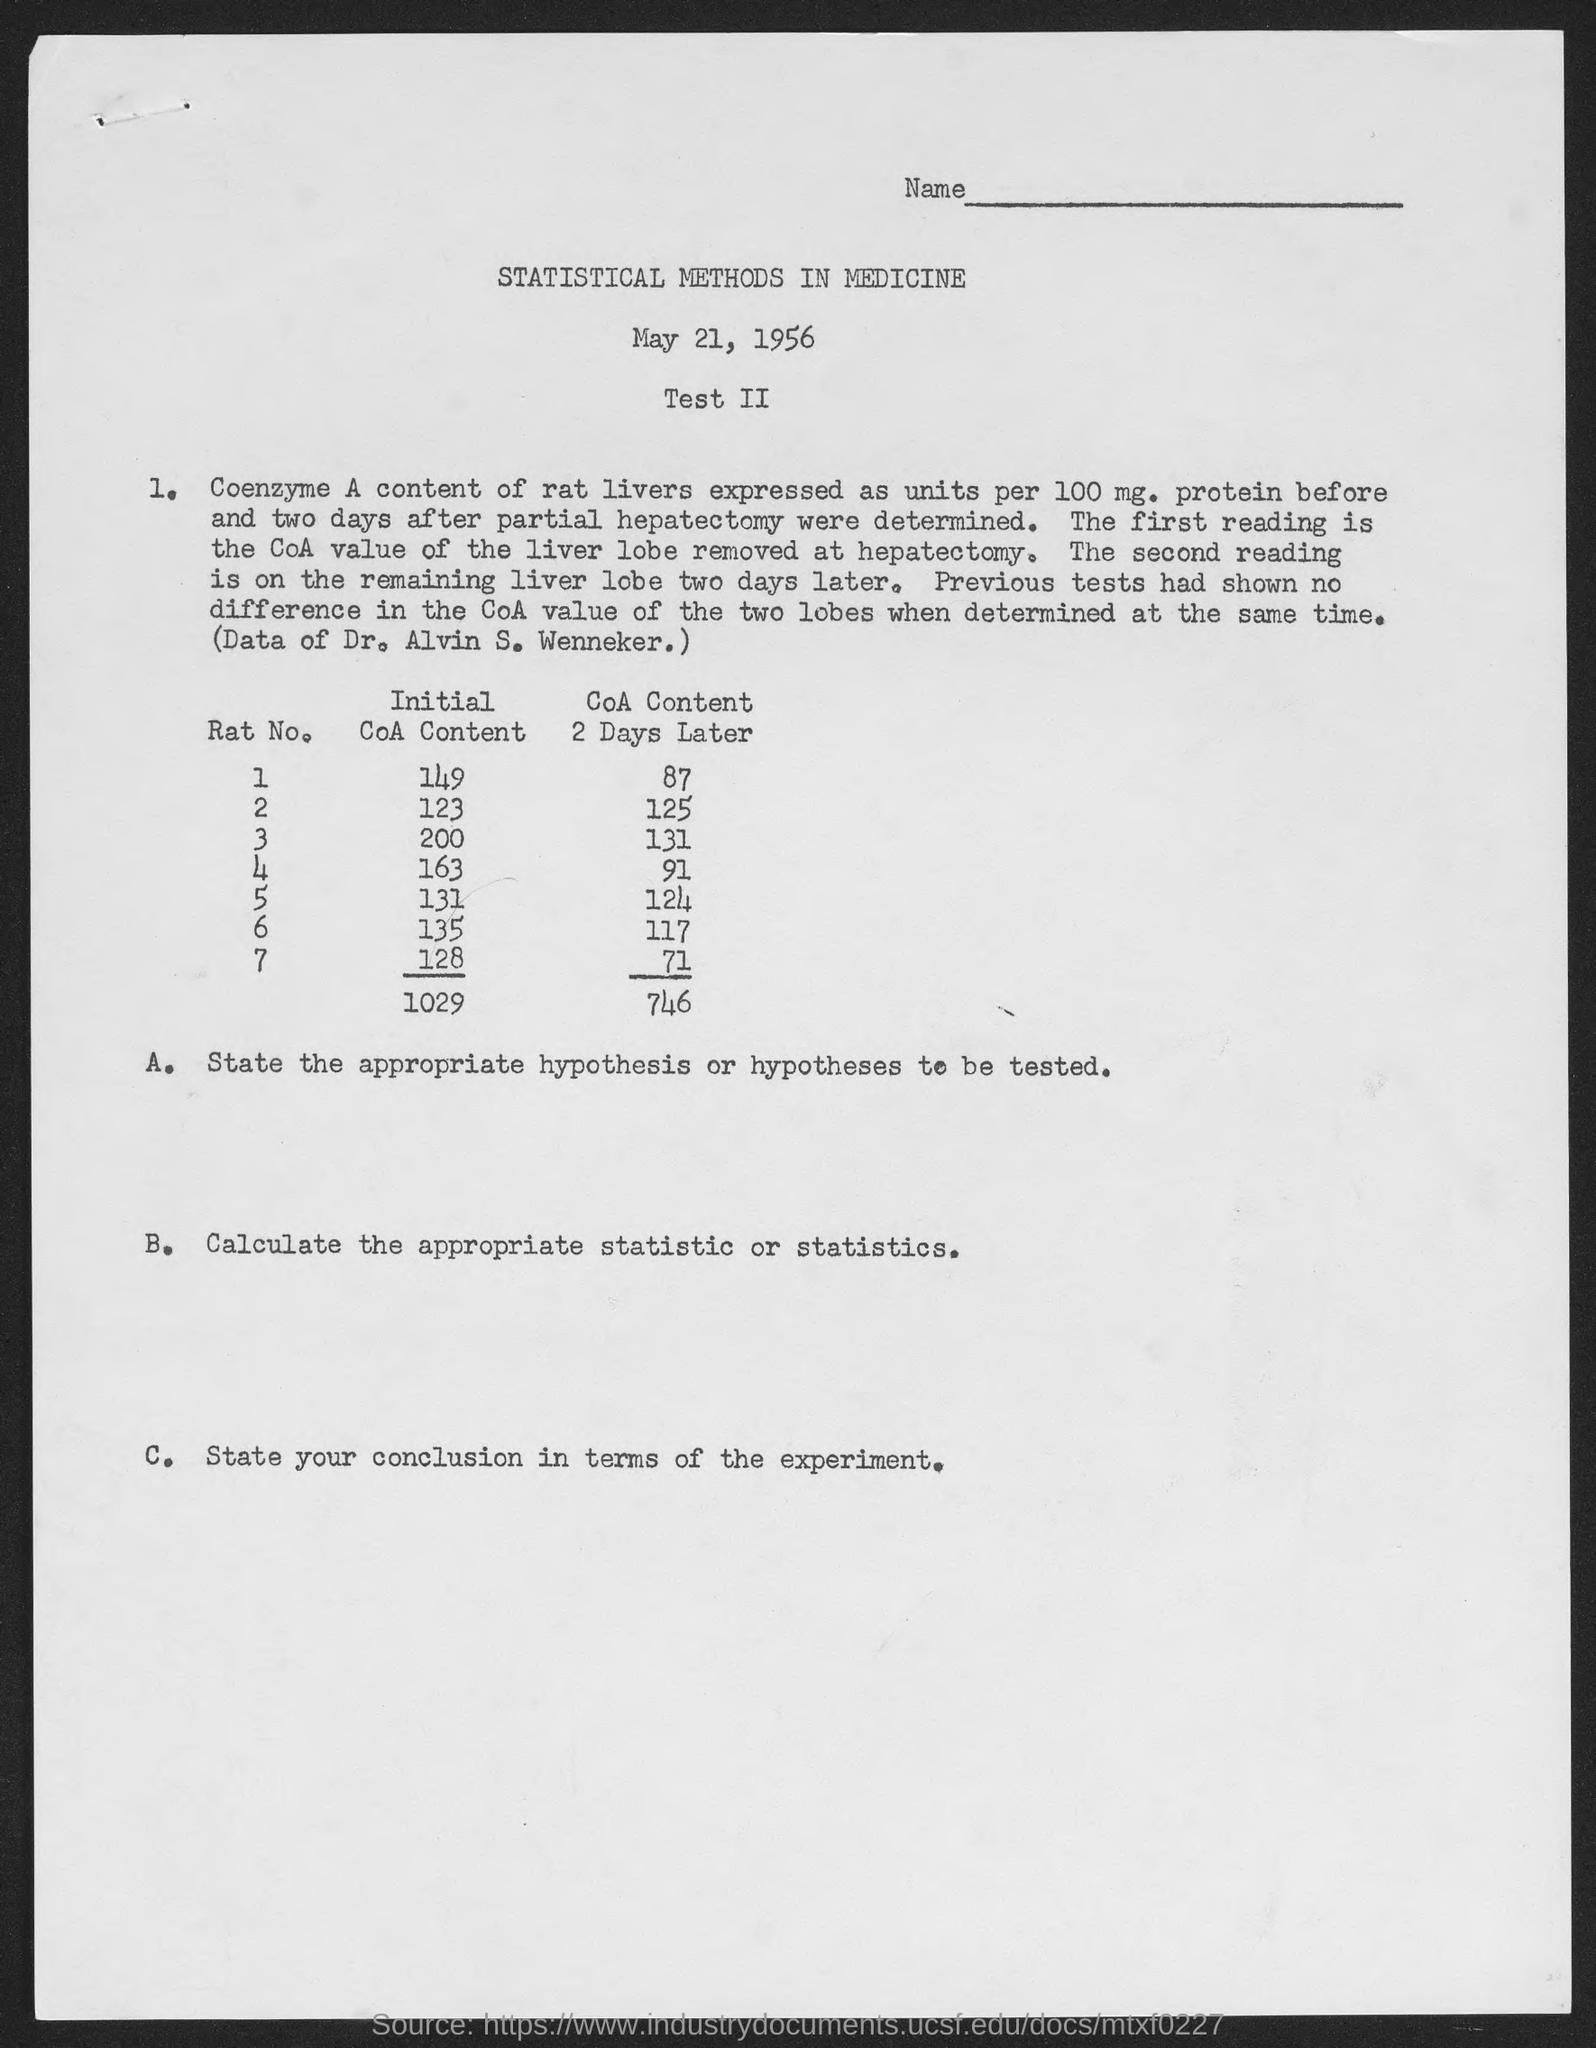What is the initial coa content in rat no. 1?
Provide a short and direct response. 149. What is the initial coa content in rat no. 2?
Ensure brevity in your answer.  123. What is the initial coa content in rat no. 3?
Give a very brief answer. 200. What is the initial coa content in rat no. 4?
Make the answer very short. 163. What is the initial coa content in rat no. 5?
Provide a succinct answer. 131. What is the initial coa content in rat no.6?
Give a very brief answer. 135. What is the initial coa content in rat no.7?
Ensure brevity in your answer.  128. What is the coa content 2 days later in rat no. 1?
Your response must be concise. 87. What is the coa content 2 days later in rat no. 2?
Make the answer very short. 125. What is the coa content 2 days later in rat no. 3?
Ensure brevity in your answer.  131. 